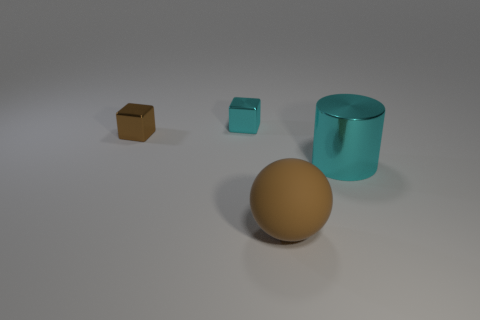Are any purple matte spheres visible?
Keep it short and to the point. No. Is the small cyan shiny thing the same shape as the brown metal thing?
Provide a succinct answer. Yes. How many small things are either cyan shiny things or shiny cubes?
Your answer should be compact. 2. The large matte thing has what color?
Give a very brief answer. Brown. What shape is the small shiny thing that is to the right of the brown object that is to the left of the large brown matte ball?
Offer a terse response. Cube. Are there any small cyan things that have the same material as the big cyan cylinder?
Offer a very short reply. Yes. There is a cyan thing on the right side of the matte sphere; is its size the same as the brown metallic cube?
Provide a succinct answer. No. What number of cyan objects are either small blocks or large objects?
Provide a short and direct response. 2. There is a small object right of the small brown shiny cube; what is it made of?
Your response must be concise. Metal. How many brown cubes are to the right of the cyan thing that is to the left of the ball?
Keep it short and to the point. 0. 